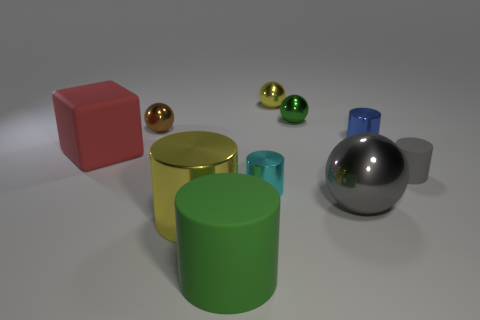Considering the arrangement, what type of setting could this image represent? This image could represent a setting for a product display or a simple scene designed for a still life composition. The careful arrangement and neutral background make it look like a showcase, perhaps for an illustration of geometric shapes, a 3D modeling demonstration, or an educational tool to study colors and shading in art or design. 